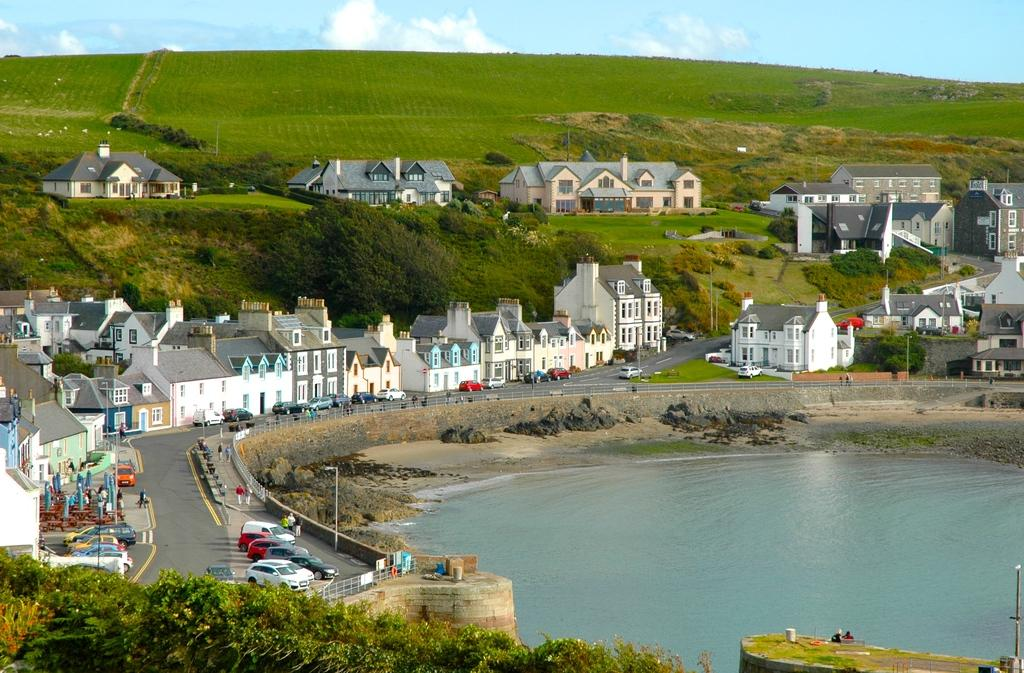What type of view is provided in the image? The image is an aerial view. What type of vegetation can be seen in the image? There are trees in the image. What type of structures are visible in the image? There are wooden houses in the image. What natural element is visible in the image? There is water visible in the image. What are the vehicles doing in the image? Vehicles are parked on the road in the image. What type of ground cover is present in the image? Grass is present in the image. What is visible in the background of the image? The sky is visible in the background of the image. What can be seen in the sky in the image? Clouds are present in the sky. What type of rhythm can be heard coming from the crook in the image? There is no crook or rhythm present in the image. 